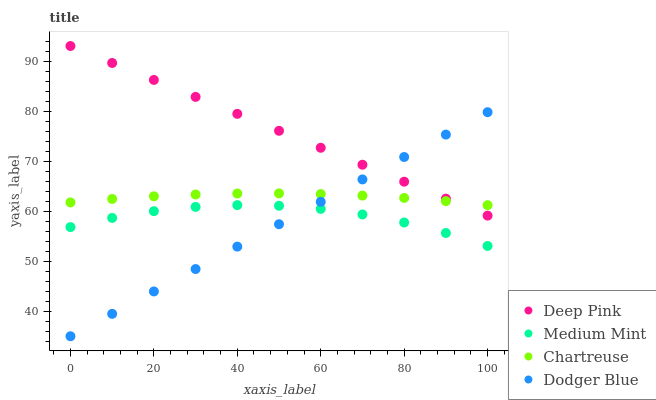Does Dodger Blue have the minimum area under the curve?
Answer yes or no. Yes. Does Deep Pink have the maximum area under the curve?
Answer yes or no. Yes. Does Chartreuse have the minimum area under the curve?
Answer yes or no. No. Does Chartreuse have the maximum area under the curve?
Answer yes or no. No. Is Dodger Blue the smoothest?
Answer yes or no. Yes. Is Medium Mint the roughest?
Answer yes or no. Yes. Is Chartreuse the smoothest?
Answer yes or no. No. Is Chartreuse the roughest?
Answer yes or no. No. Does Dodger Blue have the lowest value?
Answer yes or no. Yes. Does Deep Pink have the lowest value?
Answer yes or no. No. Does Deep Pink have the highest value?
Answer yes or no. Yes. Does Chartreuse have the highest value?
Answer yes or no. No. Is Medium Mint less than Chartreuse?
Answer yes or no. Yes. Is Chartreuse greater than Medium Mint?
Answer yes or no. Yes. Does Dodger Blue intersect Deep Pink?
Answer yes or no. Yes. Is Dodger Blue less than Deep Pink?
Answer yes or no. No. Is Dodger Blue greater than Deep Pink?
Answer yes or no. No. Does Medium Mint intersect Chartreuse?
Answer yes or no. No. 